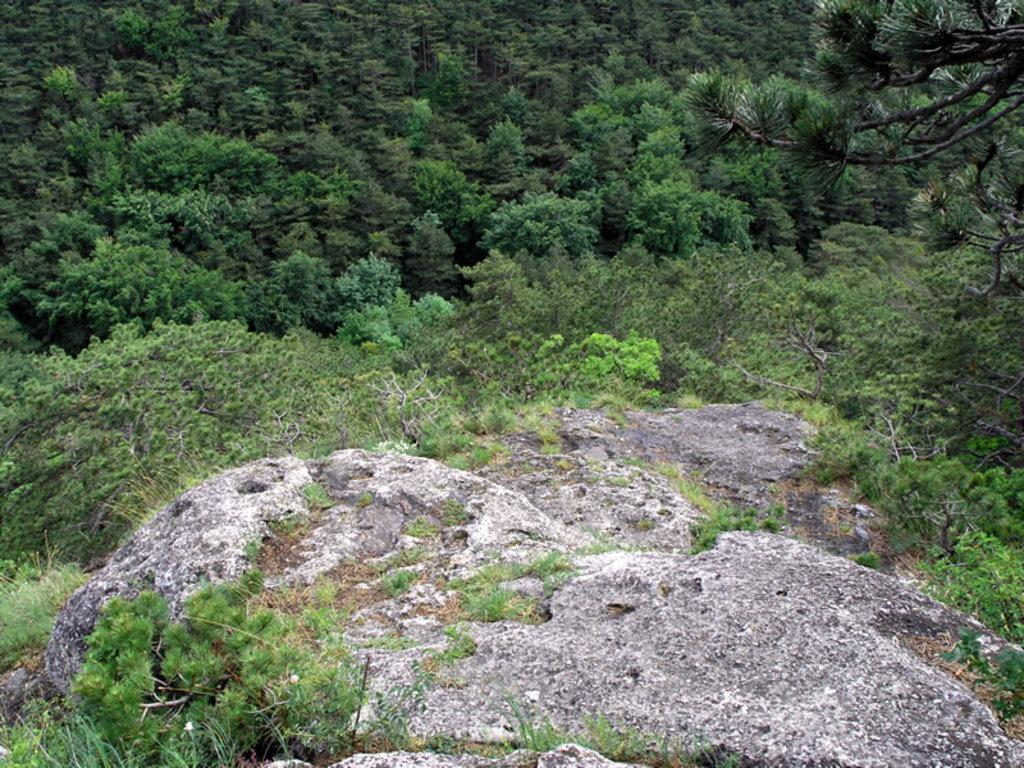What is the main object in the image? There is a rock in the image. What other natural elements can be seen in the image? There are plants and trees in the image. How many frogs are sitting on the rock in the image? There are no frogs present in the image. What type of calculator can be seen resting on the plants in the image? There is no calculator present in the image. 